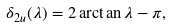Convert formula to latex. <formula><loc_0><loc_0><loc_500><loc_500>\delta _ { 2 u } ( \lambda ) = 2 \arctan \lambda - \pi ,</formula> 